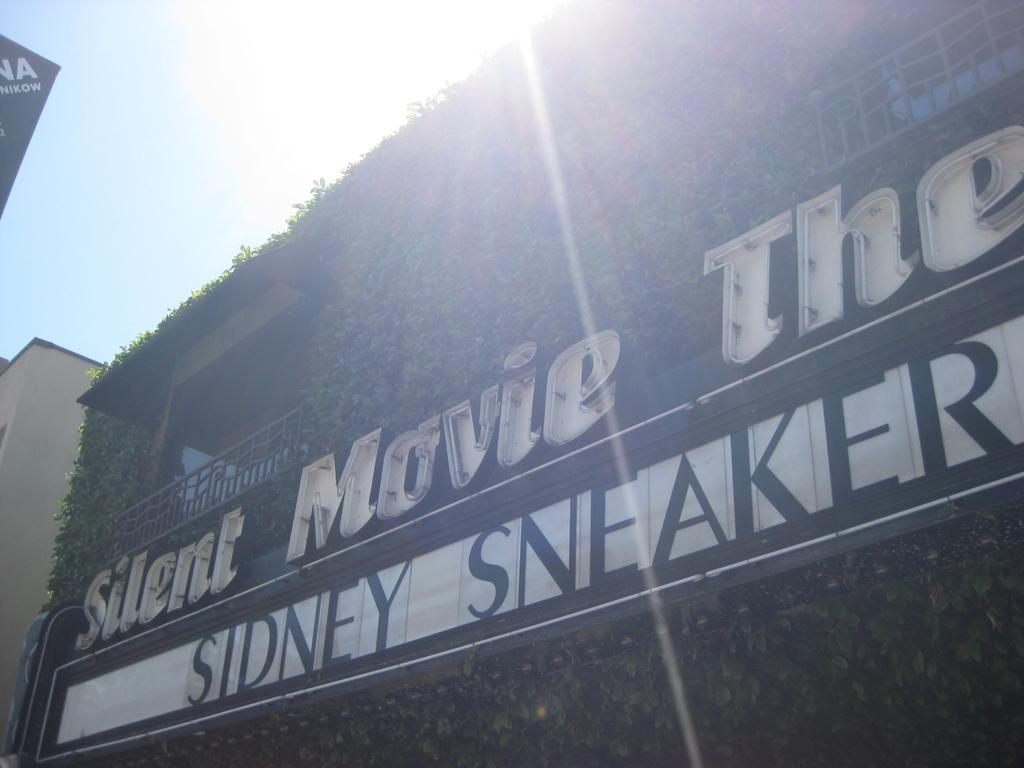Provide a one-sentence caption for the provided image. Sidney Sneaker plays at a silent movie theatre. 